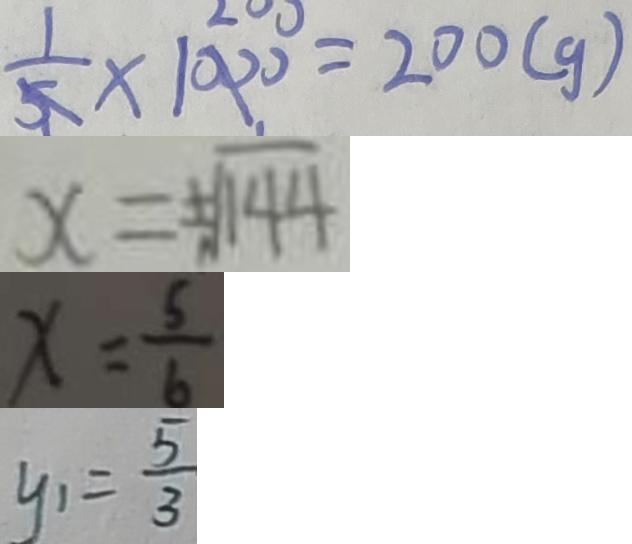<formula> <loc_0><loc_0><loc_500><loc_500>\frac { 1 } { 5 } \times 1 0 0 0 = 2 0 0 ( g ) 
 x = \pm \sqrt { 1 4 4 } 
 x = \frac { 5 } { 6 } 
 y _ { 1 } = \frac { 5 } { 3 }</formula> 